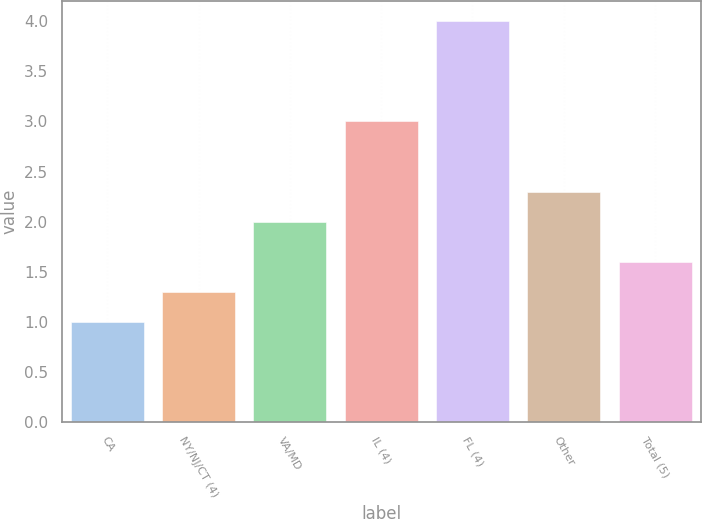Convert chart to OTSL. <chart><loc_0><loc_0><loc_500><loc_500><bar_chart><fcel>CA<fcel>NY/NJ/CT (4)<fcel>VA/MD<fcel>IL (4)<fcel>FL (4)<fcel>Other<fcel>Total (5)<nl><fcel>1<fcel>1.3<fcel>2<fcel>3<fcel>4<fcel>2.3<fcel>1.6<nl></chart> 